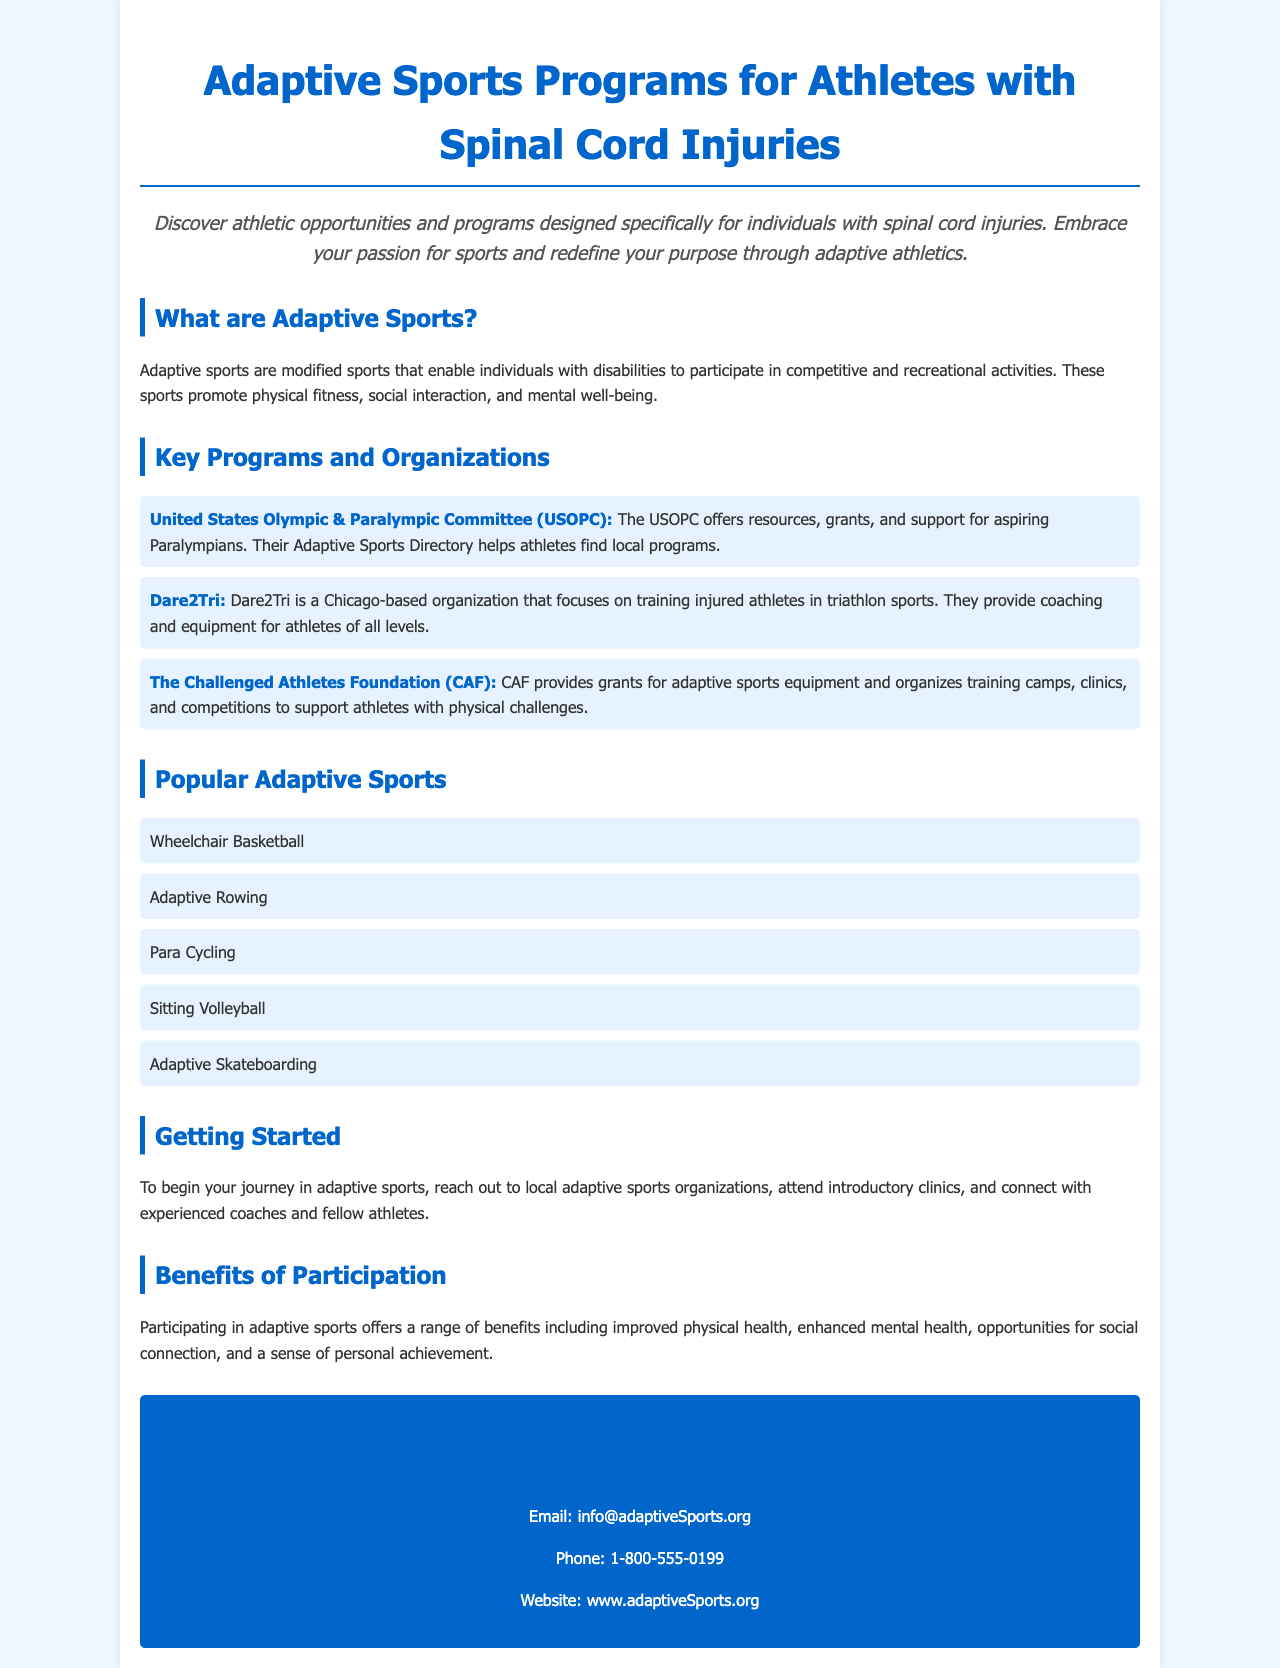What is the title of the brochure? The title appears at the top of the document, indicating the subject matter of the content.
Answer: Adaptive Sports Programs for Athletes with Spinal Cord Injuries What is an adaptive sport? The brochure defines adaptive sports in a paragraph that explains their purpose and benefits.
Answer: Modified sports Which organization focuses on training injured athletes in triathlon sports? The brochure lists organizations and their specific focuses, including Dare2Tri.
Answer: Dare2Tri What sport is listed first under popular adaptive sports? The order of the sports listed can be found in the section dedicated to popular adaptive sports.
Answer: Wheelchair Basketball What is one benefit of participating in adaptive sports? The brochure discusses multiple benefits; one of them is highlighted in the benefits section.
Answer: Improved physical health How can you contact the organization mentioned in the brochure? The contact section provides detailed information about reaching out to the organization through different means.
Answer: Email, Phone, Website What type of event does the Challenged Athletes Foundation organize? The brochure describes events organized by CAF, highlighting its role in supporting athletic opportunities.
Answer: Training camps What is the phone number provided for contact? The contact information section includes a specific phone number for inquiries.
Answer: 1-800-555-0199 What color is the heading for the "Getting Started" section? The color of the headings throughout the document follows the same theme, providing a distinct visual cue for each section.
Answer: Dark blue 